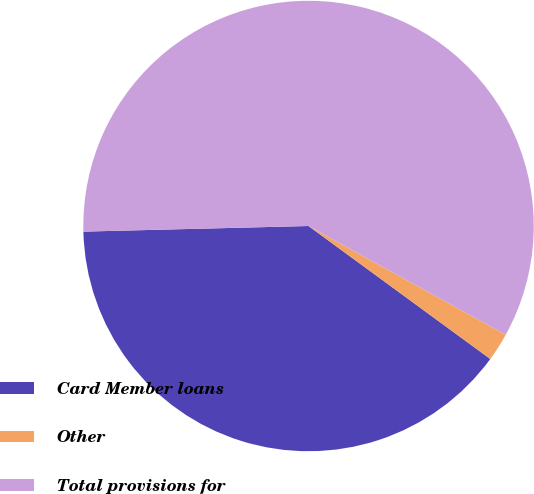Convert chart. <chart><loc_0><loc_0><loc_500><loc_500><pie_chart><fcel>Card Member loans<fcel>Other<fcel>Total provisions for<nl><fcel>39.55%<fcel>2.03%<fcel>58.42%<nl></chart> 